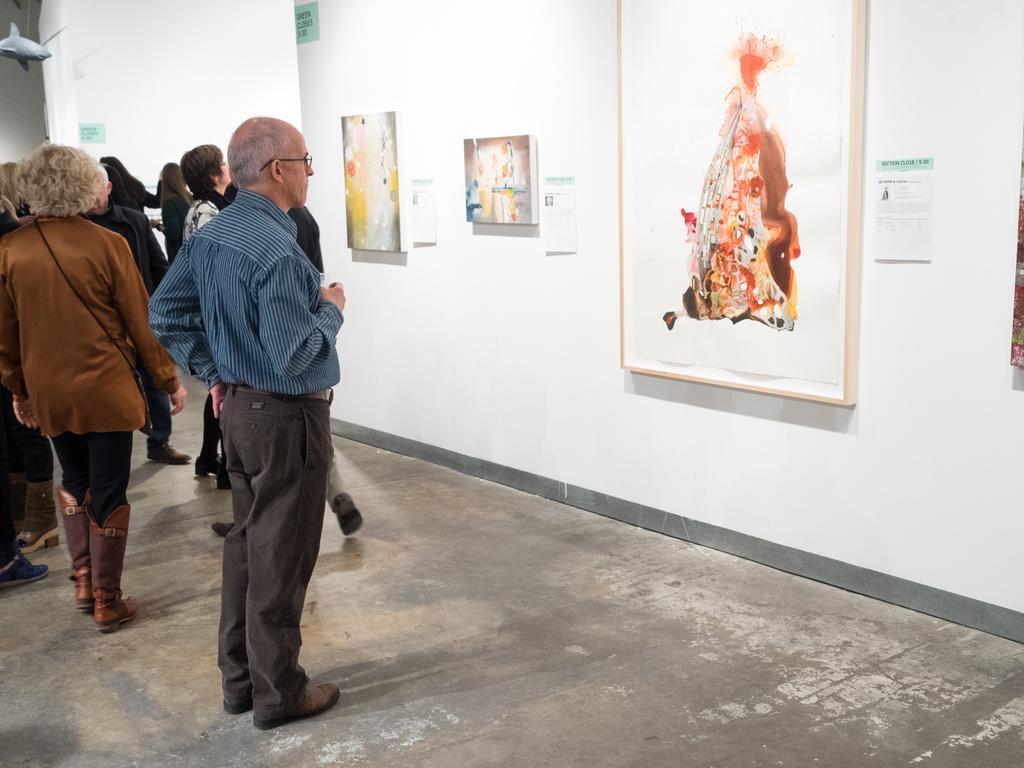How would you summarize this image in a sentence or two? Here in this picture we can see number of people standing and walking on the floor and on the right side on the wall we can see some paintings present and in the front we can see an old man standing and watching the painting, which is present in the middle. 